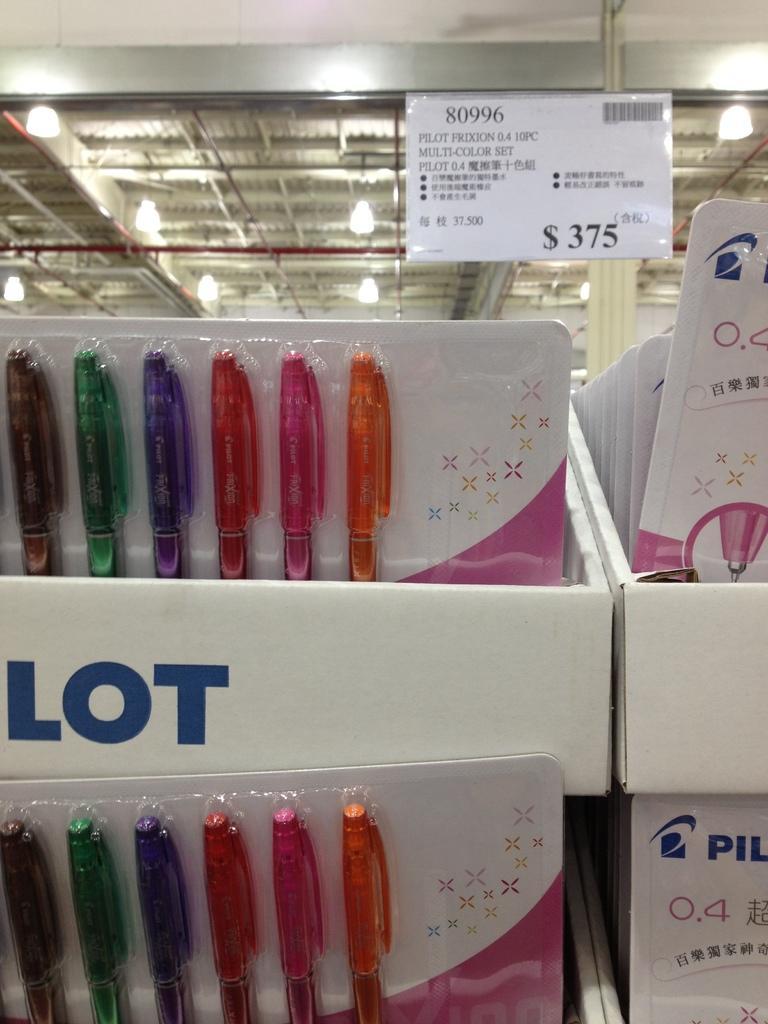Please provide a concise description of this image. Here I can see two pen packets which are placed in the white color boxes. On the box I can see some text. At the top of the image there are some lights. 